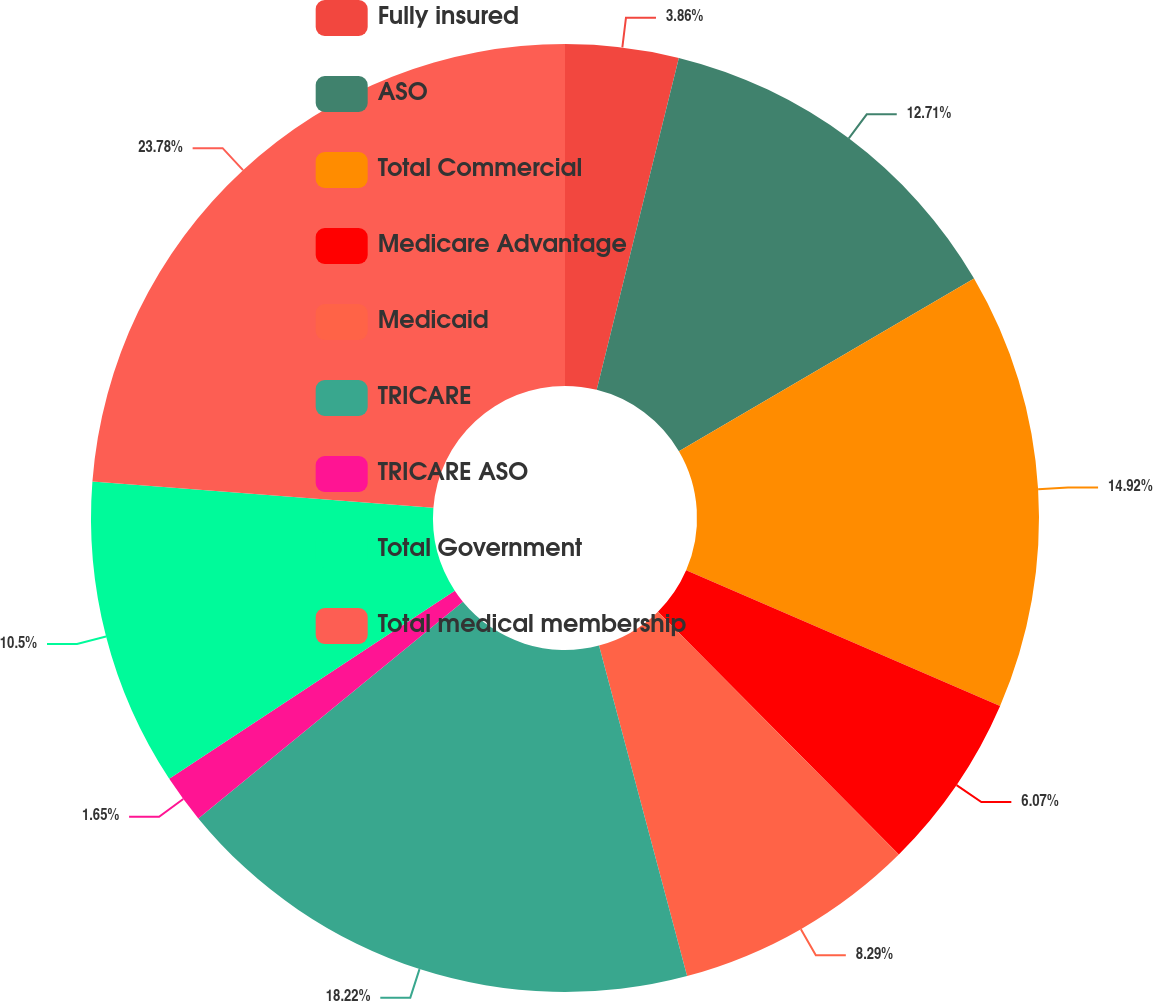Convert chart to OTSL. <chart><loc_0><loc_0><loc_500><loc_500><pie_chart><fcel>Fully insured<fcel>ASO<fcel>Total Commercial<fcel>Medicare Advantage<fcel>Medicaid<fcel>TRICARE<fcel>TRICARE ASO<fcel>Total Government<fcel>Total medical membership<nl><fcel>3.86%<fcel>12.71%<fcel>14.92%<fcel>6.07%<fcel>8.29%<fcel>18.22%<fcel>1.65%<fcel>10.5%<fcel>23.77%<nl></chart> 